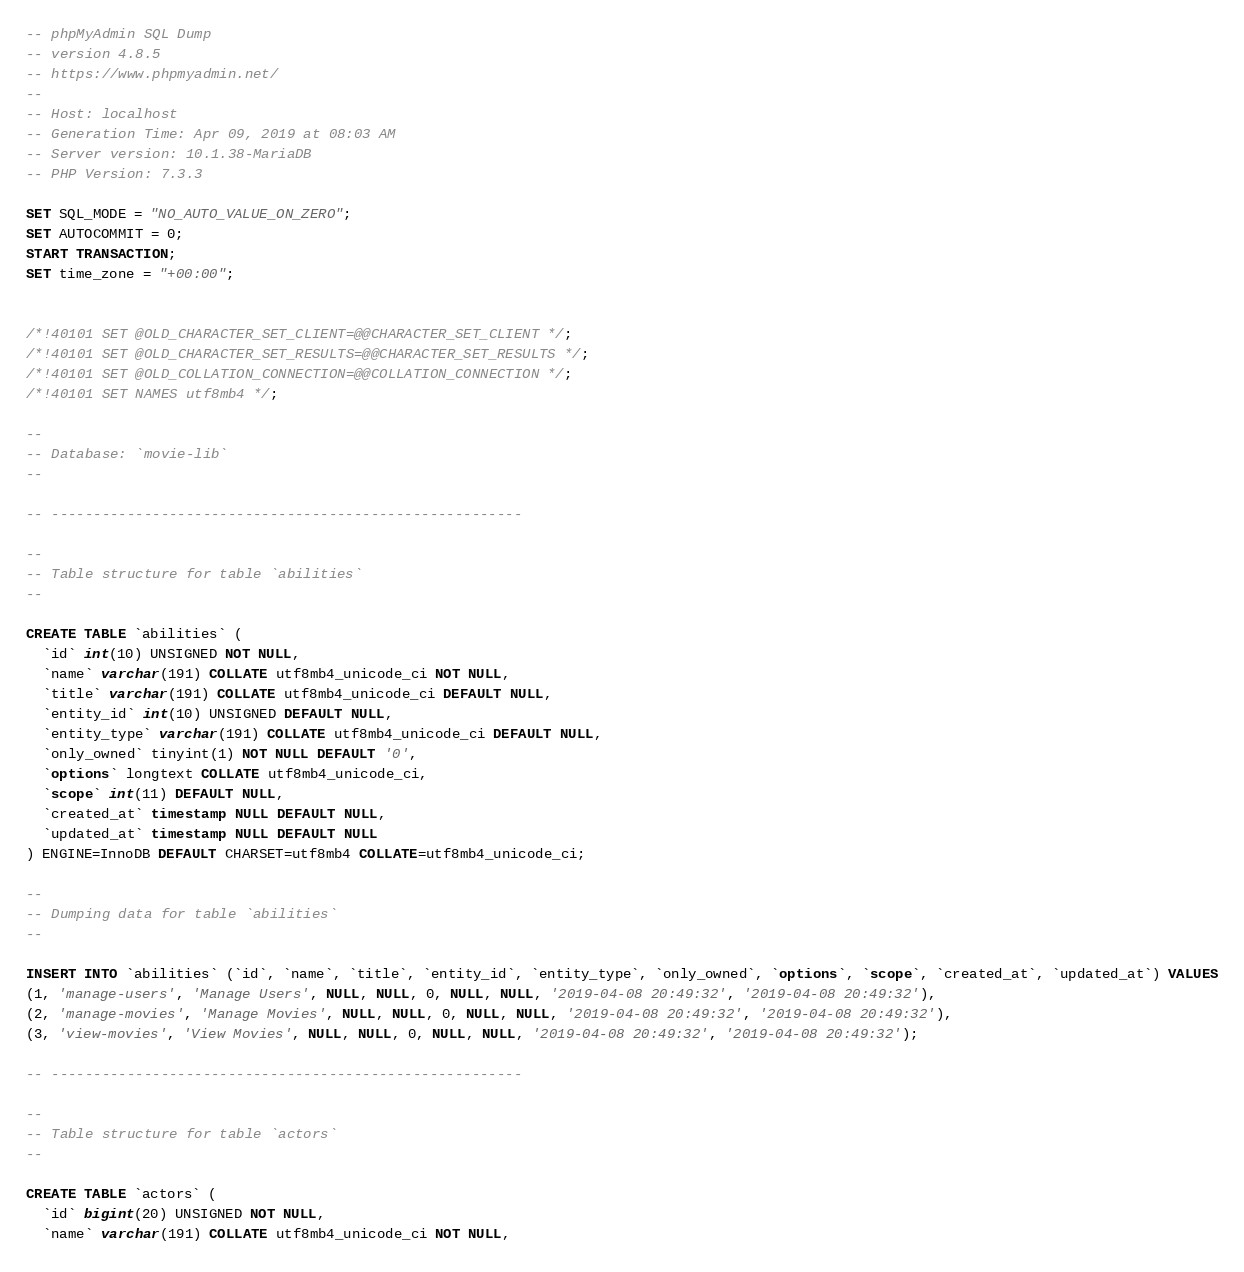Convert code to text. <code><loc_0><loc_0><loc_500><loc_500><_SQL_>-- phpMyAdmin SQL Dump
-- version 4.8.5
-- https://www.phpmyadmin.net/
--
-- Host: localhost
-- Generation Time: Apr 09, 2019 at 08:03 AM
-- Server version: 10.1.38-MariaDB
-- PHP Version: 7.3.3

SET SQL_MODE = "NO_AUTO_VALUE_ON_ZERO";
SET AUTOCOMMIT = 0;
START TRANSACTION;
SET time_zone = "+00:00";


/*!40101 SET @OLD_CHARACTER_SET_CLIENT=@@CHARACTER_SET_CLIENT */;
/*!40101 SET @OLD_CHARACTER_SET_RESULTS=@@CHARACTER_SET_RESULTS */;
/*!40101 SET @OLD_COLLATION_CONNECTION=@@COLLATION_CONNECTION */;
/*!40101 SET NAMES utf8mb4 */;

--
-- Database: `movie-lib`
--

-- --------------------------------------------------------

--
-- Table structure for table `abilities`
--

CREATE TABLE `abilities` (
  `id` int(10) UNSIGNED NOT NULL,
  `name` varchar(191) COLLATE utf8mb4_unicode_ci NOT NULL,
  `title` varchar(191) COLLATE utf8mb4_unicode_ci DEFAULT NULL,
  `entity_id` int(10) UNSIGNED DEFAULT NULL,
  `entity_type` varchar(191) COLLATE utf8mb4_unicode_ci DEFAULT NULL,
  `only_owned` tinyint(1) NOT NULL DEFAULT '0',
  `options` longtext COLLATE utf8mb4_unicode_ci,
  `scope` int(11) DEFAULT NULL,
  `created_at` timestamp NULL DEFAULT NULL,
  `updated_at` timestamp NULL DEFAULT NULL
) ENGINE=InnoDB DEFAULT CHARSET=utf8mb4 COLLATE=utf8mb4_unicode_ci;

--
-- Dumping data for table `abilities`
--

INSERT INTO `abilities` (`id`, `name`, `title`, `entity_id`, `entity_type`, `only_owned`, `options`, `scope`, `created_at`, `updated_at`) VALUES
(1, 'manage-users', 'Manage Users', NULL, NULL, 0, NULL, NULL, '2019-04-08 20:49:32', '2019-04-08 20:49:32'),
(2, 'manage-movies', 'Manage Movies', NULL, NULL, 0, NULL, NULL, '2019-04-08 20:49:32', '2019-04-08 20:49:32'),
(3, 'view-movies', 'View Movies', NULL, NULL, 0, NULL, NULL, '2019-04-08 20:49:32', '2019-04-08 20:49:32');

-- --------------------------------------------------------

--
-- Table structure for table `actors`
--

CREATE TABLE `actors` (
  `id` bigint(20) UNSIGNED NOT NULL,
  `name` varchar(191) COLLATE utf8mb4_unicode_ci NOT NULL,</code> 